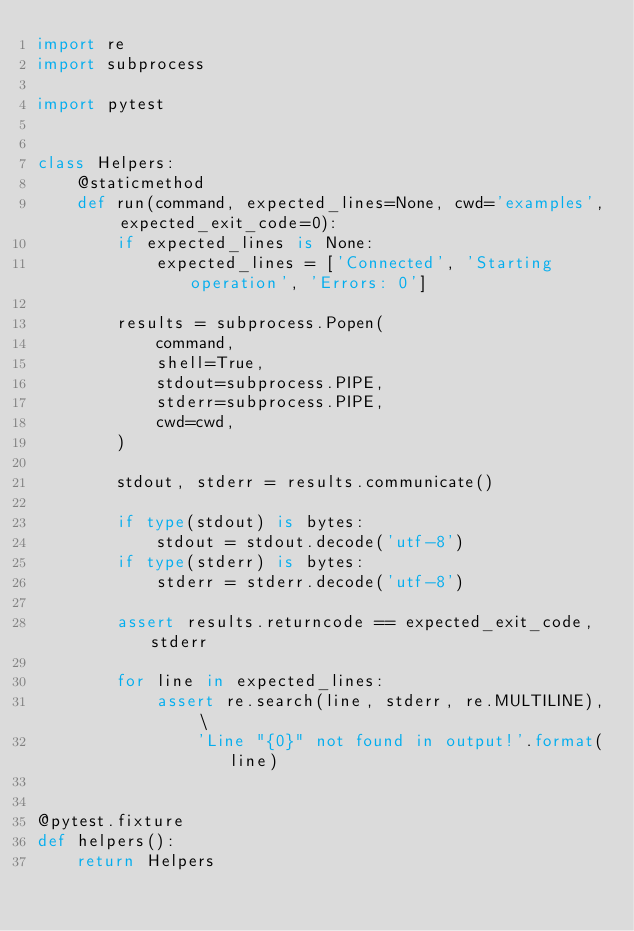Convert code to text. <code><loc_0><loc_0><loc_500><loc_500><_Python_>import re
import subprocess

import pytest


class Helpers:
    @staticmethod
    def run(command, expected_lines=None, cwd='examples', expected_exit_code=0):
        if expected_lines is None:
            expected_lines = ['Connected', 'Starting operation', 'Errors: 0']

        results = subprocess.Popen(
            command,
            shell=True,
            stdout=subprocess.PIPE,
            stderr=subprocess.PIPE,
            cwd=cwd,
        )

        stdout, stderr = results.communicate()

        if type(stdout) is bytes:
            stdout = stdout.decode('utf-8')
        if type(stderr) is bytes:
            stderr = stderr.decode('utf-8')

        assert results.returncode == expected_exit_code, stderr

        for line in expected_lines:
            assert re.search(line, stderr, re.MULTILINE), \
                'Line "{0}" not found in output!'.format(line)


@pytest.fixture
def helpers():
    return Helpers
</code> 